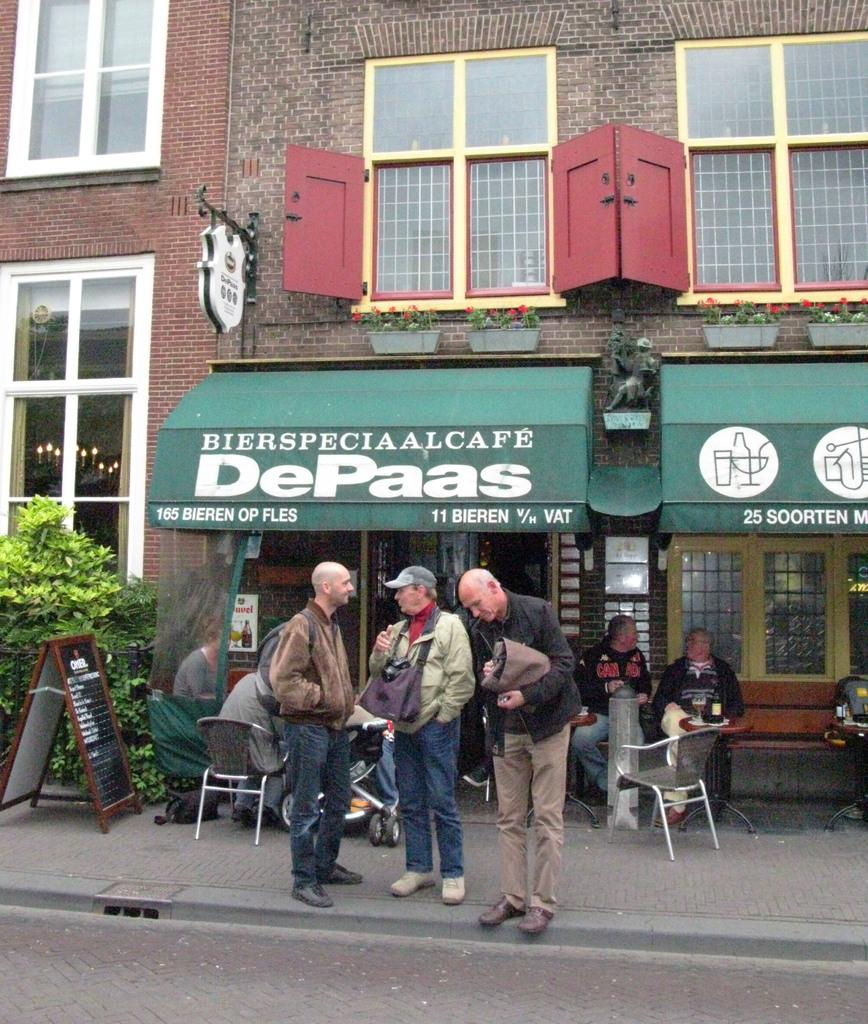How many people are standing on the path in the image? There are three people standing on the path in the image. What are the other people in the image doing? There are people sitting on chairs in the image. What can be seen behind the people? There is a board visible behind the people. What type of natural environment is visible in the background? Trees are present in the background. What type of man-made structure is visible in the background? There is a building in the background. What type of meal is being served on the board in the image? There is no meal present on the board in the image; it is a board with unspecified content. What type of bushes are growing near the trees in the background? There is no mention of bushes in the image; only trees are mentioned in the background. 